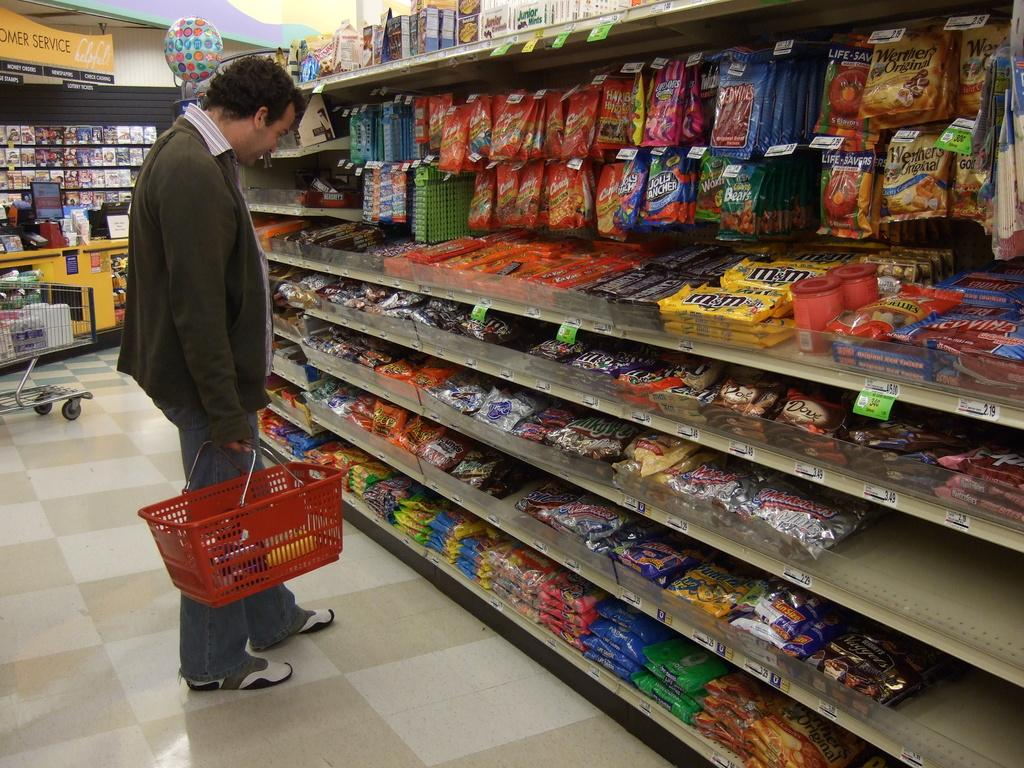Provide a one-sentence caption for the provided image. A man wearing a brown sweater standing in a grocery store looking at a rack of m&m candies among other brands. 